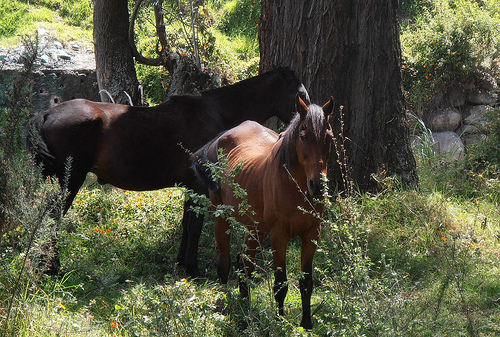<image>
Is there a tree behind the flower? Yes. From this viewpoint, the tree is positioned behind the flower, with the flower partially or fully occluding the tree. 